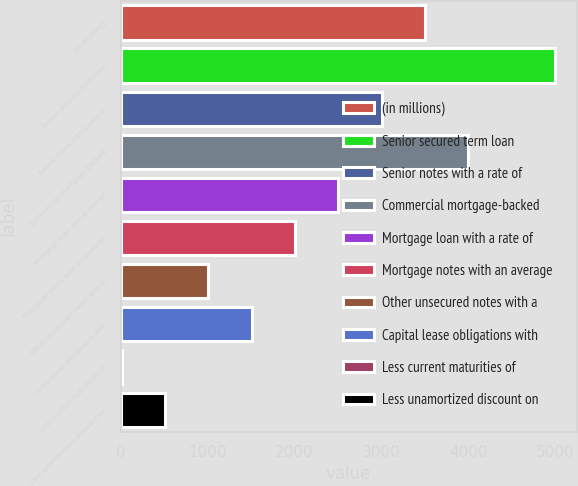Convert chart to OTSL. <chart><loc_0><loc_0><loc_500><loc_500><bar_chart><fcel>(in millions)<fcel>Senior secured term loan<fcel>Senior notes with a rate of<fcel>Commercial mortgage-backed<fcel>Mortgage loan with a rate of<fcel>Mortgage notes with an average<fcel>Other unsecured notes with a<fcel>Capital lease obligations with<fcel>Less current maturities of<fcel>Less unamortized discount on<nl><fcel>3503<fcel>5000<fcel>3004<fcel>4002<fcel>2505<fcel>2006<fcel>1008<fcel>1507<fcel>10<fcel>509<nl></chart> 